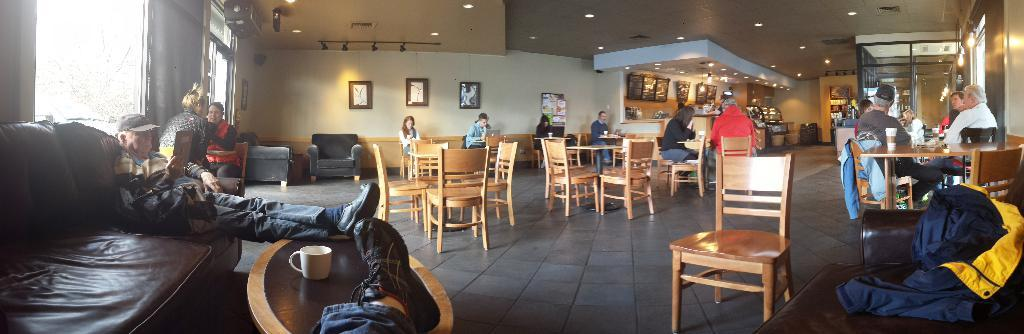What are the people in the image doing? The people in the image are sitting on chairs. What is the man in the image sitting on? The man is sitting on a sofa in the image. What is the man doing with his leg? The man is leaning his leg on a table in the image. How many jellyfish are visible in the image? There are no jellyfish present in the image. What type of snakes can be seen slithering on the floor in the image? There are no snakes present in the image. 